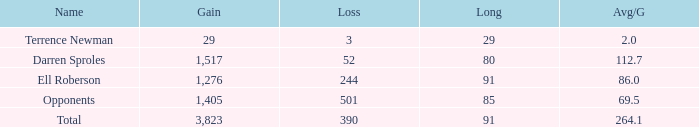When the player gained below 1,405 yards and lost over 390 yards, what's the sum of the long yards? None. 